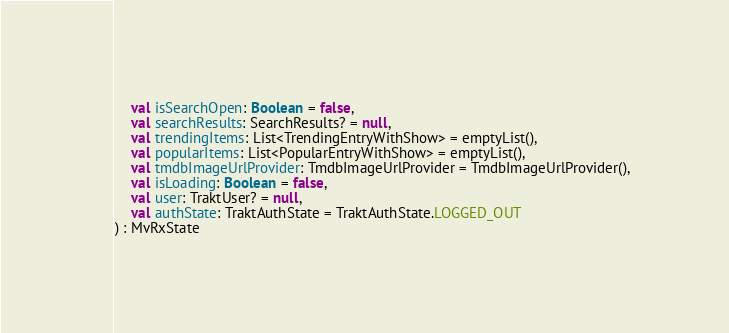Convert code to text. <code><loc_0><loc_0><loc_500><loc_500><_Kotlin_>    val isSearchOpen: Boolean = false,
    val searchResults: SearchResults? = null,
    val trendingItems: List<TrendingEntryWithShow> = emptyList(),
    val popularItems: List<PopularEntryWithShow> = emptyList(),
    val tmdbImageUrlProvider: TmdbImageUrlProvider = TmdbImageUrlProvider(),
    val isLoading: Boolean = false,
    val user: TraktUser? = null,
    val authState: TraktAuthState = TraktAuthState.LOGGED_OUT
) : MvRxState</code> 